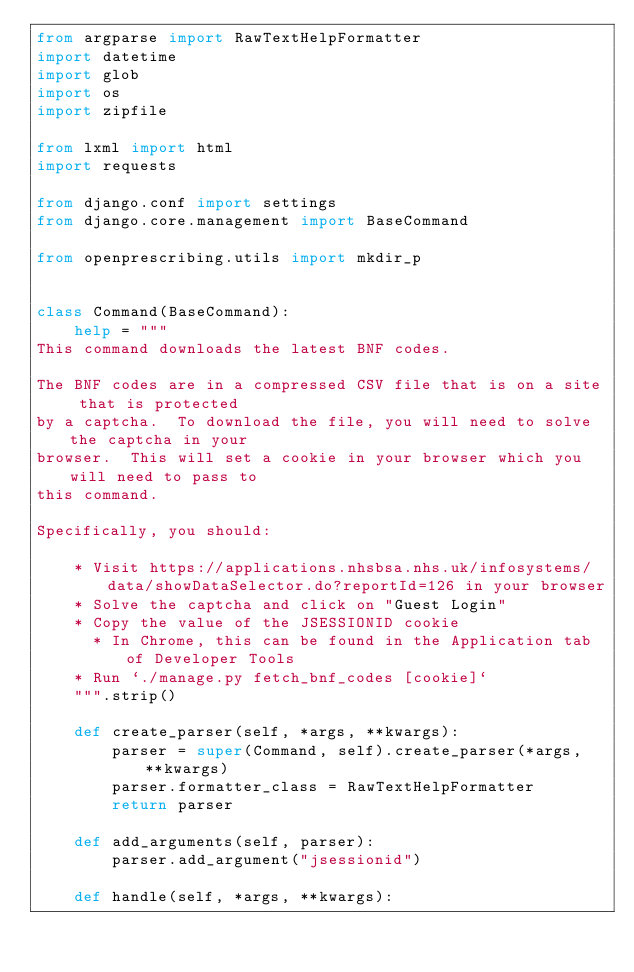Convert code to text. <code><loc_0><loc_0><loc_500><loc_500><_Python_>from argparse import RawTextHelpFormatter
import datetime
import glob
import os
import zipfile

from lxml import html
import requests

from django.conf import settings
from django.core.management import BaseCommand

from openprescribing.utils import mkdir_p


class Command(BaseCommand):
    help = """
This command downloads the latest BNF codes.

The BNF codes are in a compressed CSV file that is on a site that is protected
by a captcha.  To download the file, you will need to solve the captcha in your
browser.  This will set a cookie in your browser which you will need to pass to
this command.

Specifically, you should:

    * Visit https://applications.nhsbsa.nhs.uk/infosystems/data/showDataSelector.do?reportId=126 in your browser
    * Solve the captcha and click on "Guest Login"
    * Copy the value of the JSESSIONID cookie
      * In Chrome, this can be found in the Application tab of Developer Tools
    * Run `./manage.py fetch_bnf_codes [cookie]`
    """.strip()

    def create_parser(self, *args, **kwargs):
        parser = super(Command, self).create_parser(*args, **kwargs)
        parser.formatter_class = RawTextHelpFormatter
        return parser

    def add_arguments(self, parser):
        parser.add_argument("jsessionid")

    def handle(self, *args, **kwargs):</code> 